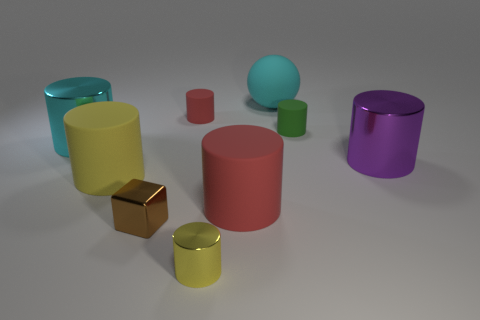Subtract all cyan metal cylinders. How many cylinders are left? 6 Subtract all red cylinders. How many cylinders are left? 5 Subtract all green cylinders. Subtract all purple cubes. How many cylinders are left? 6 Add 1 big blue objects. How many objects exist? 10 Subtract all cylinders. How many objects are left? 2 Add 2 metal things. How many metal things exist? 6 Subtract 0 red spheres. How many objects are left? 9 Subtract all large matte balls. Subtract all red matte objects. How many objects are left? 6 Add 7 big red cylinders. How many big red cylinders are left? 8 